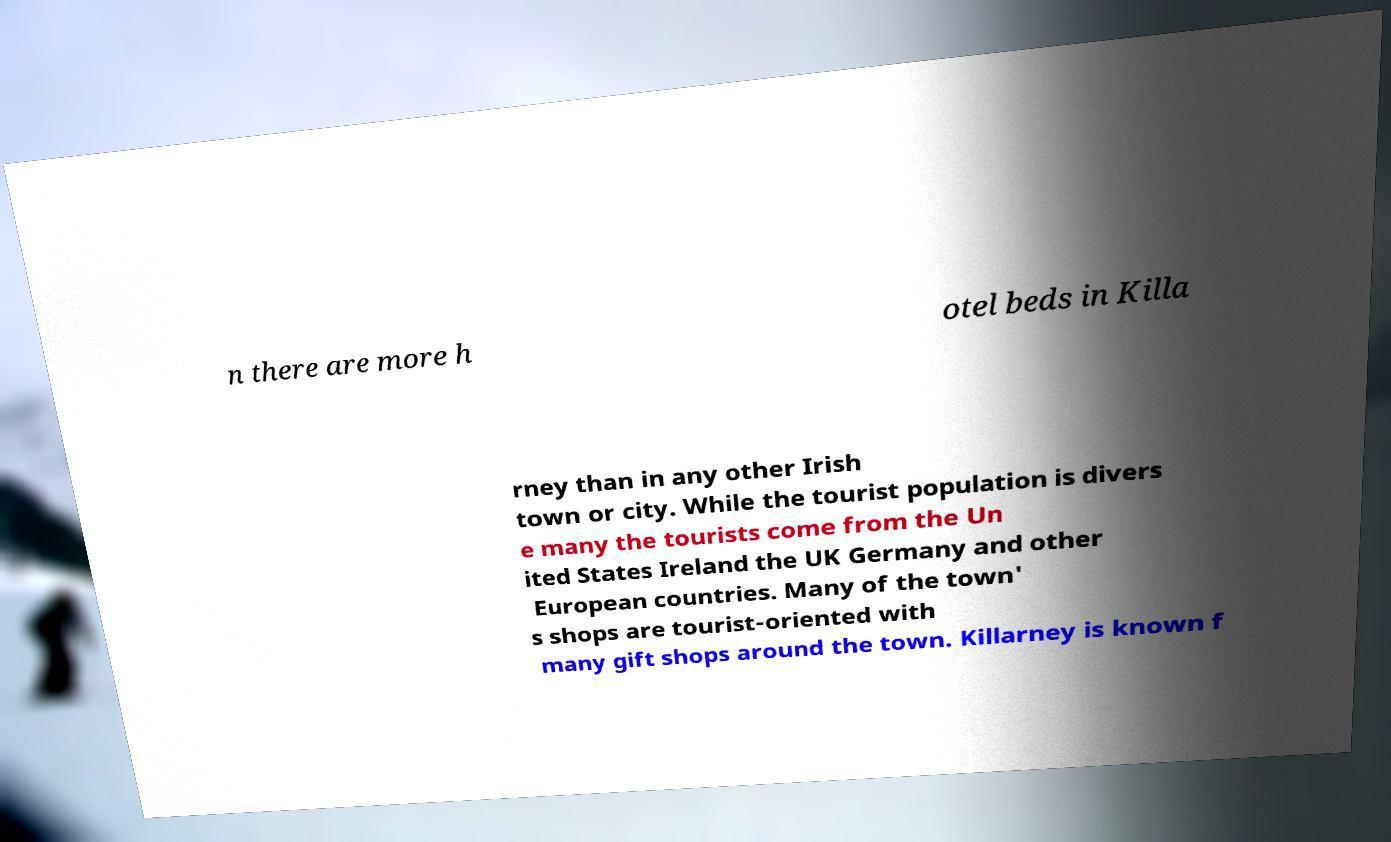Could you extract and type out the text from this image? n there are more h otel beds in Killa rney than in any other Irish town or city. While the tourist population is divers e many the tourists come from the Un ited States Ireland the UK Germany and other European countries. Many of the town' s shops are tourist-oriented with many gift shops around the town. Killarney is known f 